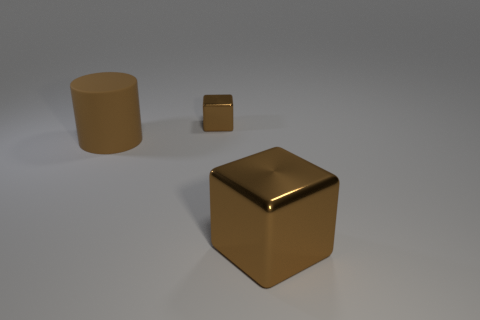Add 2 green metallic objects. How many objects exist? 5 Subtract all blocks. How many objects are left? 1 Add 2 large things. How many large things exist? 4 Subtract 1 brown cylinders. How many objects are left? 2 Subtract all purple blocks. Subtract all brown things. How many objects are left? 0 Add 1 tiny brown shiny things. How many tiny brown shiny things are left? 2 